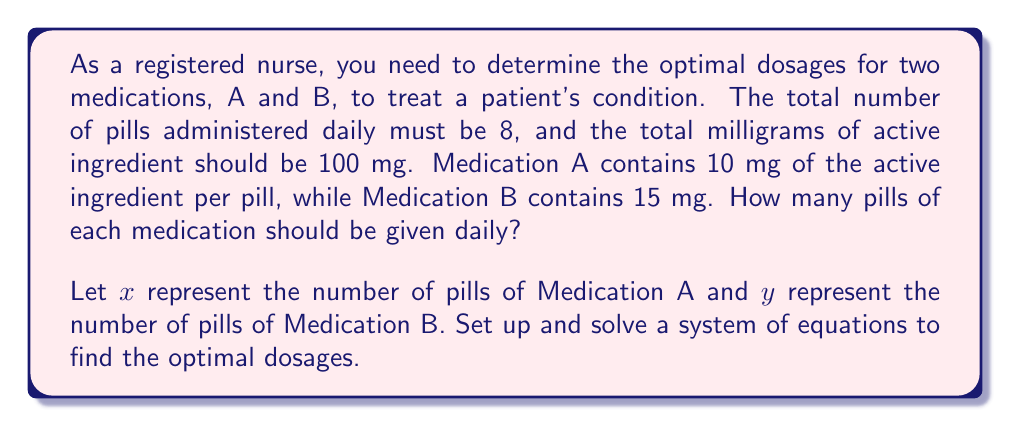Teach me how to tackle this problem. To solve this problem, we need to set up a system of two equations based on the given information:

1. The total number of pills must be 8:
   $$x + y = 8$$

2. The total milligrams of active ingredient should be 100 mg:
   $$10x + 15y = 100$$

Now, let's solve this system of equations using the substitution method:

1. From the first equation, we can express $y$ in terms of $x$:
   $$y = 8 - x$$

2. Substitute this expression for $y$ into the second equation:
   $$10x + 15(8 - x) = 100$$

3. Simplify the equation:
   $$10x + 120 - 15x = 100$$
   $$-5x + 120 = 100$$

4. Solve for $x$:
   $$-5x = -20$$
   $$x = 4$$

5. Now that we know $x$, we can find $y$ using the equation from step 1:
   $$y = 8 - x = 8 - 4 = 4$$

Therefore, the optimal dosage is 4 pills of Medication A and 4 pills of Medication B daily.

To verify:
- Total number of pills: $4 + 4 = 8$
- Total milligrams of active ingredient: $(4 \times 10) + (4 \times 15) = 40 + 60 = 100$ mg
Answer: The optimal dosage is 4 pills of Medication A and 4 pills of Medication B daily. 